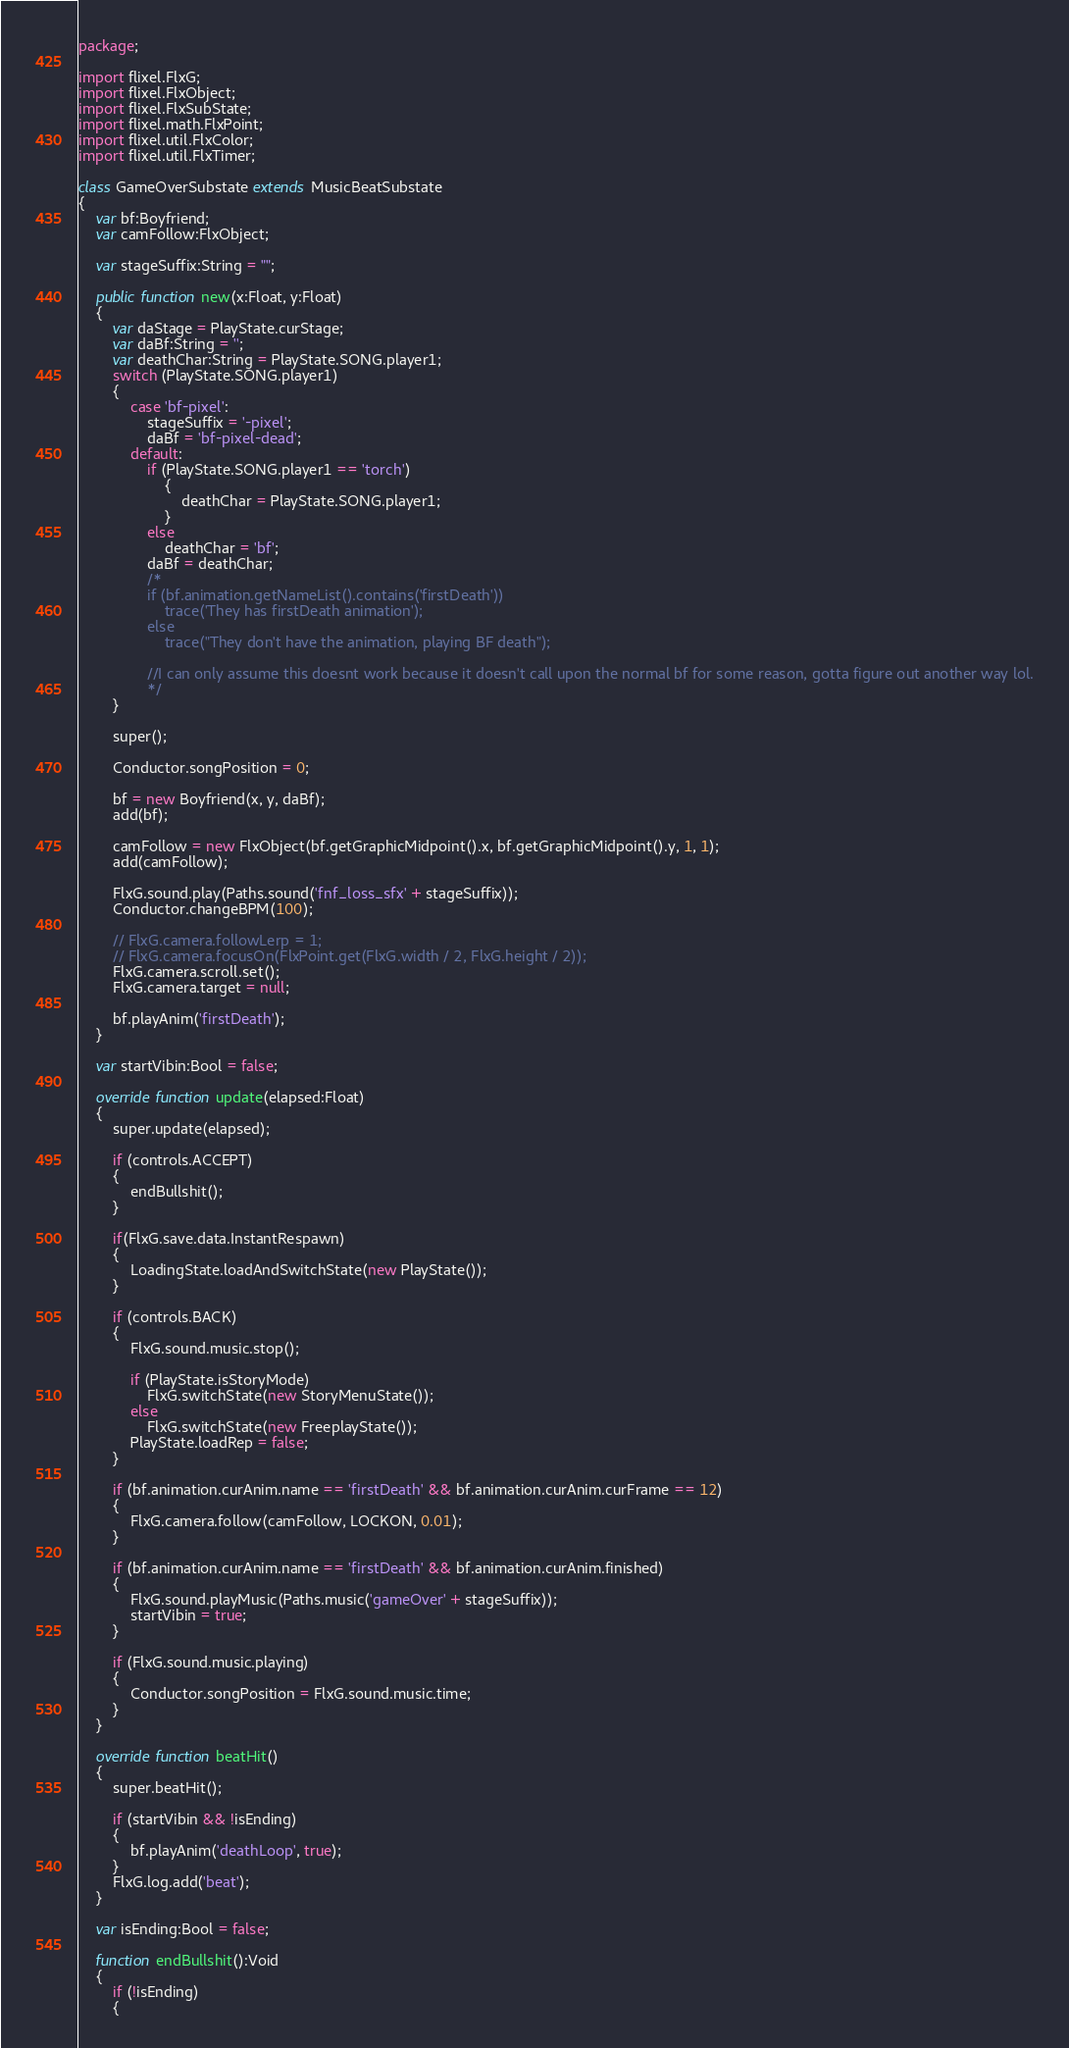Convert code to text. <code><loc_0><loc_0><loc_500><loc_500><_Haxe_>package;

import flixel.FlxG;
import flixel.FlxObject;
import flixel.FlxSubState;
import flixel.math.FlxPoint;
import flixel.util.FlxColor;
import flixel.util.FlxTimer;

class GameOverSubstate extends MusicBeatSubstate
{
	var bf:Boyfriend;
	var camFollow:FlxObject;

	var stageSuffix:String = "";

	public function new(x:Float, y:Float)
	{
		var daStage = PlayState.curStage;
		var daBf:String = '';
		var deathChar:String = PlayState.SONG.player1;
		switch (PlayState.SONG.player1)
		{
			case 'bf-pixel':
				stageSuffix = '-pixel';
				daBf = 'bf-pixel-dead';
			default:
				if (PlayState.SONG.player1 == 'torch')
					{
						deathChar = PlayState.SONG.player1;
					}
				else
					deathChar = 'bf';
				daBf = deathChar;
				/*
				if (bf.animation.getNameList().contains('firstDeath'))
					trace('They has firstDeath animation');
				else
					trace("They don't have the animation, playing BF death");
				
				//I can only assume this doesnt work because it doesn't call upon the normal bf for some reason, gotta figure out another way lol.
				*/
		}

		super();

		Conductor.songPosition = 0;

		bf = new Boyfriend(x, y, daBf);
		add(bf);

		camFollow = new FlxObject(bf.getGraphicMidpoint().x, bf.getGraphicMidpoint().y, 1, 1);
		add(camFollow);

		FlxG.sound.play(Paths.sound('fnf_loss_sfx' + stageSuffix));
		Conductor.changeBPM(100);

		// FlxG.camera.followLerp = 1;
		// FlxG.camera.focusOn(FlxPoint.get(FlxG.width / 2, FlxG.height / 2));
		FlxG.camera.scroll.set();
		FlxG.camera.target = null;

		bf.playAnim('firstDeath');
	}

	var startVibin:Bool = false;

	override function update(elapsed:Float)
	{
		super.update(elapsed);

		if (controls.ACCEPT)
		{
			endBullshit();
		}

		if(FlxG.save.data.InstantRespawn)
		{
			LoadingState.loadAndSwitchState(new PlayState());
		}

		if (controls.BACK)
		{
			FlxG.sound.music.stop();

			if (PlayState.isStoryMode)
				FlxG.switchState(new StoryMenuState());
			else
				FlxG.switchState(new FreeplayState());
			PlayState.loadRep = false;
		}

		if (bf.animation.curAnim.name == 'firstDeath' && bf.animation.curAnim.curFrame == 12)
		{
			FlxG.camera.follow(camFollow, LOCKON, 0.01);
		}

		if (bf.animation.curAnim.name == 'firstDeath' && bf.animation.curAnim.finished)
		{
			FlxG.sound.playMusic(Paths.music('gameOver' + stageSuffix));
			startVibin = true;
		}

		if (FlxG.sound.music.playing)
		{
			Conductor.songPosition = FlxG.sound.music.time;
		}
	}

	override function beatHit()
	{
		super.beatHit();

		if (startVibin && !isEnding)
		{
			bf.playAnim('deathLoop', true);
		}
		FlxG.log.add('beat');
	}

	var isEnding:Bool = false;

	function endBullshit():Void
	{
		if (!isEnding)
		{</code> 